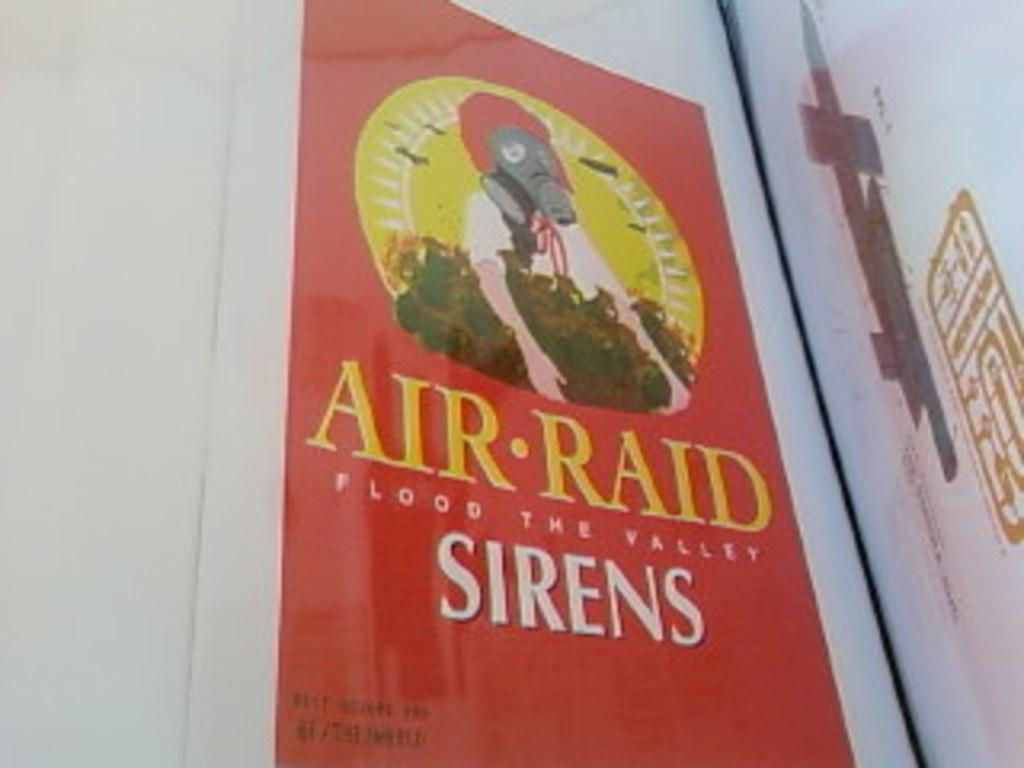<image>
Relay a brief, clear account of the picture shown. An image of someone in what looks like a gas mask has the words Air Raid Flood the Valley: Sirens. 